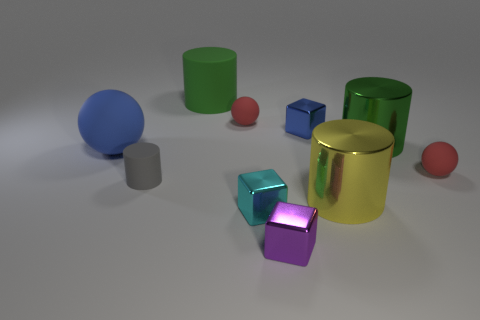Subtract all green cubes. How many red spheres are left? 2 Subtract 1 balls. How many balls are left? 2 Subtract all large rubber cylinders. How many cylinders are left? 3 Subtract all blocks. How many objects are left? 7 Subtract all cyan cylinders. Subtract all gray blocks. How many cylinders are left? 4 Subtract all gray cylinders. Subtract all small blue metal blocks. How many objects are left? 8 Add 4 large rubber objects. How many large rubber objects are left? 6 Add 1 purple objects. How many purple objects exist? 2 Subtract 0 red cylinders. How many objects are left? 10 